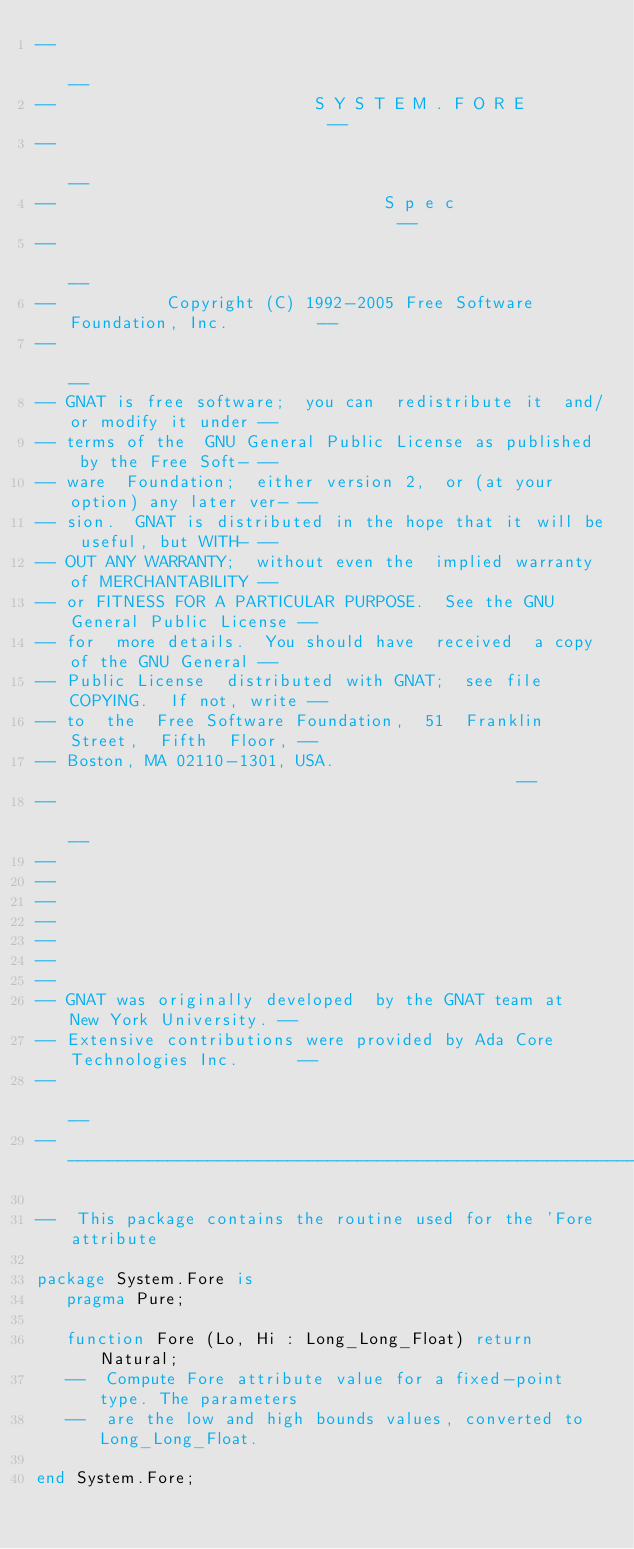Convert code to text. <code><loc_0><loc_0><loc_500><loc_500><_Ada_>--                                                                          --
--                          S Y S T E M . F O R E                           --
--                                                                          --
--                                 S p e c                                  --
--                                                                          --
--           Copyright (C) 1992-2005 Free Software Foundation, Inc.         --
--                                                                          --
-- GNAT is free software;  you can  redistribute it  and/or modify it under --
-- terms of the  GNU General Public License as published  by the Free Soft- --
-- ware  Foundation;  either version 2,  or (at your option) any later ver- --
-- sion.  GNAT is distributed in the hope that it will be useful, but WITH- --
-- OUT ANY WARRANTY;  without even the  implied warranty of MERCHANTABILITY --
-- or FITNESS FOR A PARTICULAR PURPOSE.  See the GNU General Public License --
-- for  more details.  You should have  received  a copy of the GNU General --
-- Public License  distributed with GNAT;  see file COPYING.  If not, write --
-- to  the  Free Software Foundation,  51  Franklin  Street,  Fifth  Floor, --
-- Boston, MA 02110-1301, USA.                                              --
--                                                                          --
--
--
--
--
--
--
--
-- GNAT was originally developed  by the GNAT team at  New York University. --
-- Extensive contributions were provided by Ada Core Technologies Inc.      --
--                                                                          --
------------------------------------------------------------------------------

--  This package contains the routine used for the 'Fore attribute

package System.Fore is
   pragma Pure;

   function Fore (Lo, Hi : Long_Long_Float) return Natural;
   --  Compute Fore attribute value for a fixed-point type. The parameters
   --  are the low and high bounds values, converted to Long_Long_Float.

end System.Fore;
</code> 